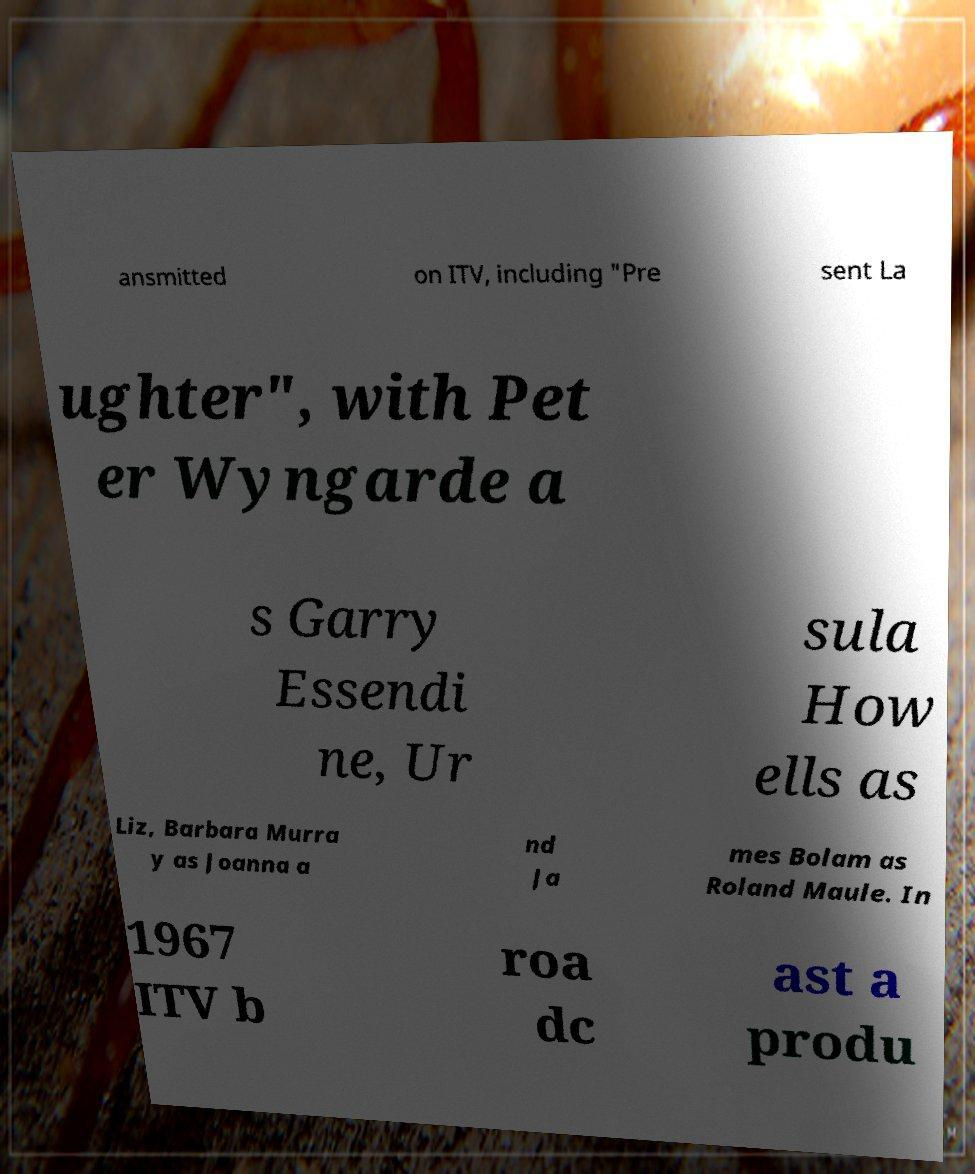Could you extract and type out the text from this image? ansmitted on ITV, including "Pre sent La ughter", with Pet er Wyngarde a s Garry Essendi ne, Ur sula How ells as Liz, Barbara Murra y as Joanna a nd Ja mes Bolam as Roland Maule. In 1967 ITV b roa dc ast a produ 